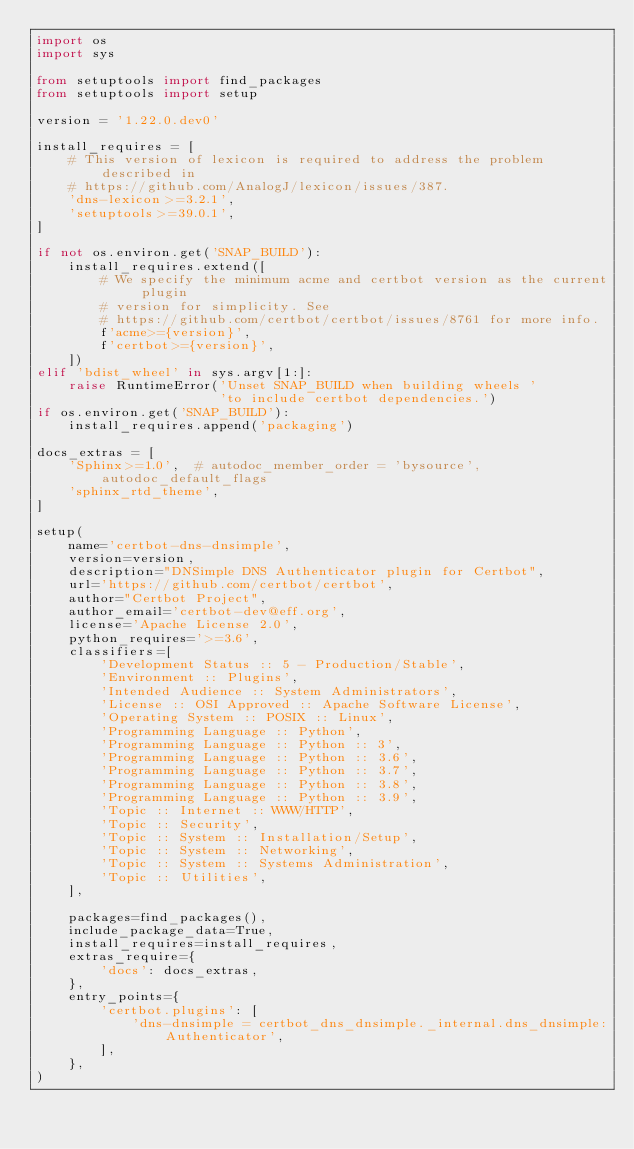Convert code to text. <code><loc_0><loc_0><loc_500><loc_500><_Python_>import os
import sys

from setuptools import find_packages
from setuptools import setup

version = '1.22.0.dev0'

install_requires = [
    # This version of lexicon is required to address the problem described in
    # https://github.com/AnalogJ/lexicon/issues/387.
    'dns-lexicon>=3.2.1',
    'setuptools>=39.0.1',
]

if not os.environ.get('SNAP_BUILD'):
    install_requires.extend([
        # We specify the minimum acme and certbot version as the current plugin
        # version for simplicity. See
        # https://github.com/certbot/certbot/issues/8761 for more info.
        f'acme>={version}',
        f'certbot>={version}',
    ])
elif 'bdist_wheel' in sys.argv[1:]:
    raise RuntimeError('Unset SNAP_BUILD when building wheels '
                       'to include certbot dependencies.')
if os.environ.get('SNAP_BUILD'):
    install_requires.append('packaging')

docs_extras = [
    'Sphinx>=1.0',  # autodoc_member_order = 'bysource', autodoc_default_flags
    'sphinx_rtd_theme',
]

setup(
    name='certbot-dns-dnsimple',
    version=version,
    description="DNSimple DNS Authenticator plugin for Certbot",
    url='https://github.com/certbot/certbot',
    author="Certbot Project",
    author_email='certbot-dev@eff.org',
    license='Apache License 2.0',
    python_requires='>=3.6',
    classifiers=[
        'Development Status :: 5 - Production/Stable',
        'Environment :: Plugins',
        'Intended Audience :: System Administrators',
        'License :: OSI Approved :: Apache Software License',
        'Operating System :: POSIX :: Linux',
        'Programming Language :: Python',
        'Programming Language :: Python :: 3',
        'Programming Language :: Python :: 3.6',
        'Programming Language :: Python :: 3.7',
        'Programming Language :: Python :: 3.8',
        'Programming Language :: Python :: 3.9',
        'Topic :: Internet :: WWW/HTTP',
        'Topic :: Security',
        'Topic :: System :: Installation/Setup',
        'Topic :: System :: Networking',
        'Topic :: System :: Systems Administration',
        'Topic :: Utilities',
    ],

    packages=find_packages(),
    include_package_data=True,
    install_requires=install_requires,
    extras_require={
        'docs': docs_extras,
    },
    entry_points={
        'certbot.plugins': [
            'dns-dnsimple = certbot_dns_dnsimple._internal.dns_dnsimple:Authenticator',
        ],
    },
)
</code> 